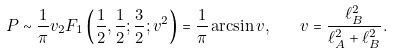<formula> <loc_0><loc_0><loc_500><loc_500>P \sim \frac { 1 } { \pi } v _ { 2 } F _ { 1 } \left ( \frac { 1 } { 2 } , \frac { 1 } { 2 } ; \frac { 3 } { 2 } ; v ^ { 2 } \right ) = \frac { 1 } { \pi } \arcsin v , \quad v = \frac { \ell _ { B } ^ { 2 } } { \ell _ { A } ^ { 2 } + \ell _ { B } ^ { 2 } } .</formula> 